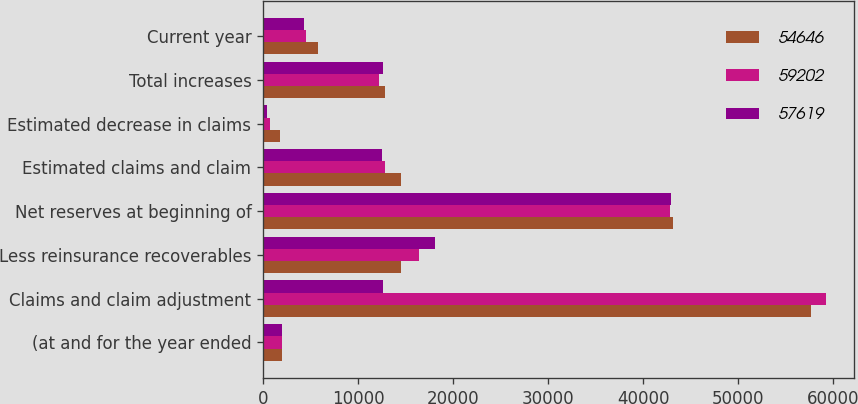<chart> <loc_0><loc_0><loc_500><loc_500><stacked_bar_chart><ecel><fcel>(at and for the year ended<fcel>Claims and claim adjustment<fcel>Less reinsurance recoverables<fcel>Net reserves at beginning of<fcel>Estimated claims and claim<fcel>Estimated decrease in claims<fcel>Total increases<fcel>Current year<nl><fcel>54646<fcel>2008<fcel>57619<fcel>14521<fcel>43098<fcel>14504<fcel>1725<fcel>12779<fcel>5761<nl><fcel>59202<fcel>2007<fcel>59202<fcel>16358<fcel>42844<fcel>12848<fcel>672<fcel>12176<fcel>4528<nl><fcel>57619<fcel>2006<fcel>12642<fcel>18112<fcel>42895<fcel>12533<fcel>429<fcel>12642<fcel>4279<nl></chart> 